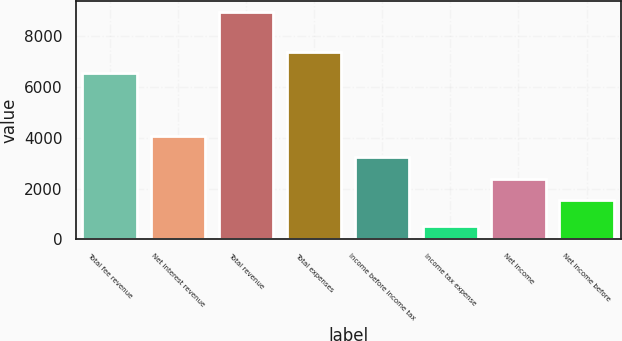Convert chart. <chart><loc_0><loc_0><loc_500><loc_500><bar_chart><fcel>Total fee revenue<fcel>Net interest revenue<fcel>Total revenue<fcel>Total expenses<fcel>Income before income tax<fcel>Income tax expense<fcel>Net income<fcel>Net income before<nl><fcel>6540<fcel>4066.9<fcel>8953<fcel>7382.3<fcel>3224.6<fcel>530<fcel>2382.3<fcel>1540<nl></chart> 